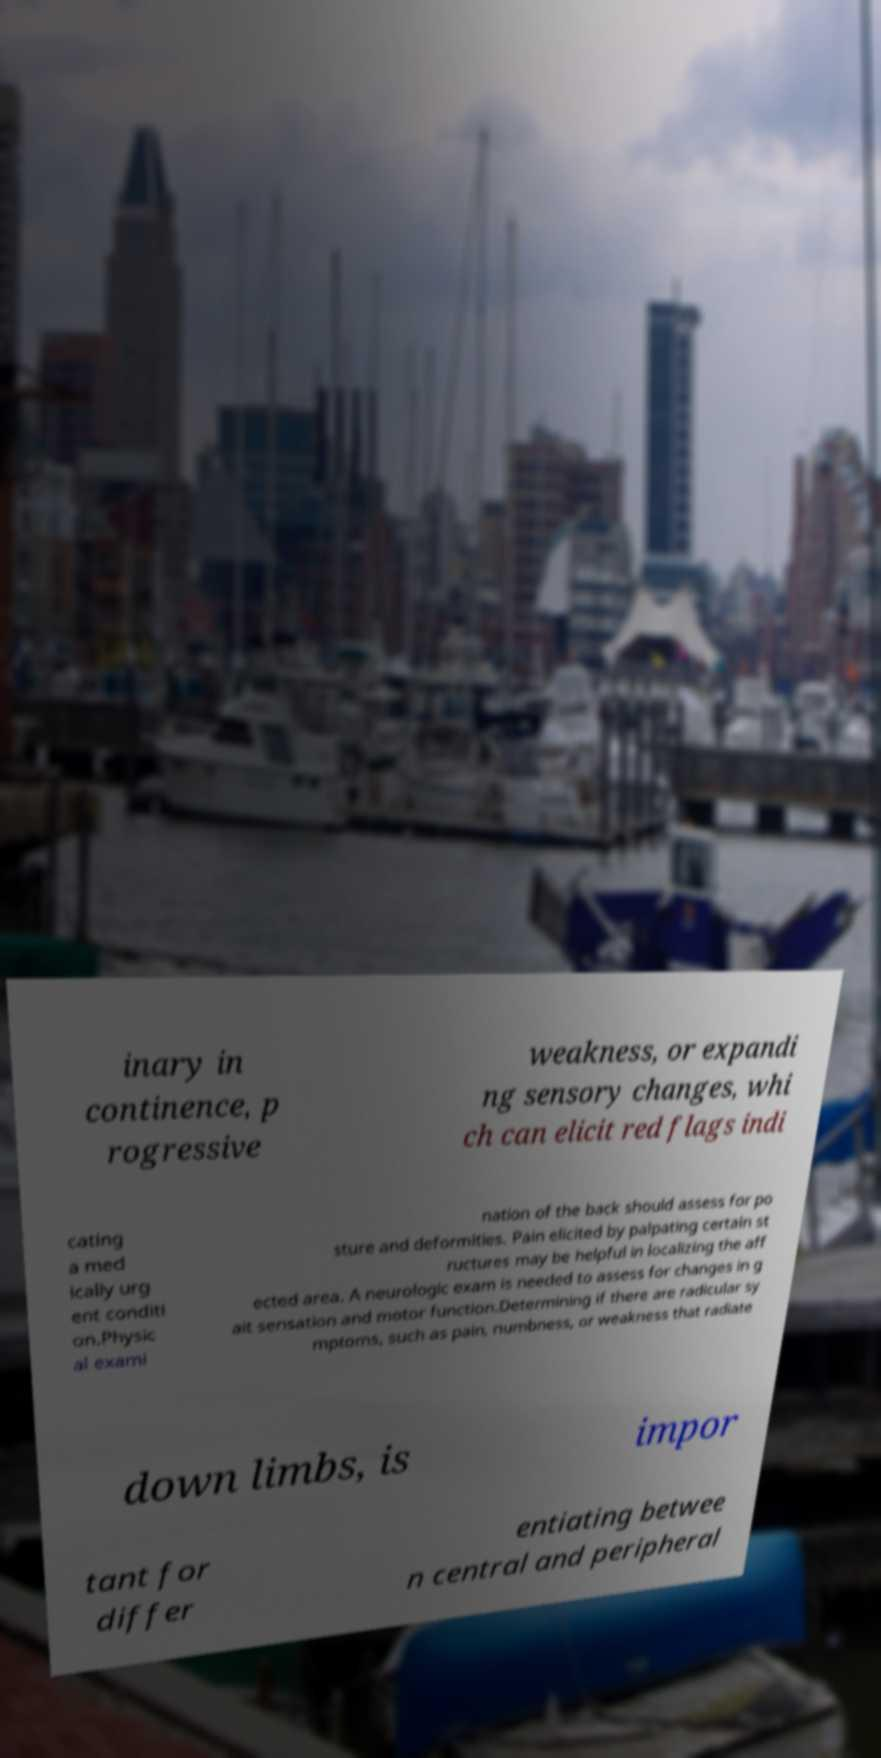Please read and relay the text visible in this image. What does it say? inary in continence, p rogressive weakness, or expandi ng sensory changes, whi ch can elicit red flags indi cating a med ically urg ent conditi on.Physic al exami nation of the back should assess for po sture and deformities. Pain elicited by palpating certain st ructures may be helpful in localizing the aff ected area. A neurologic exam is needed to assess for changes in g ait sensation and motor function.Determining if there are radicular sy mptoms, such as pain, numbness, or weakness that radiate down limbs, is impor tant for differ entiating betwee n central and peripheral 